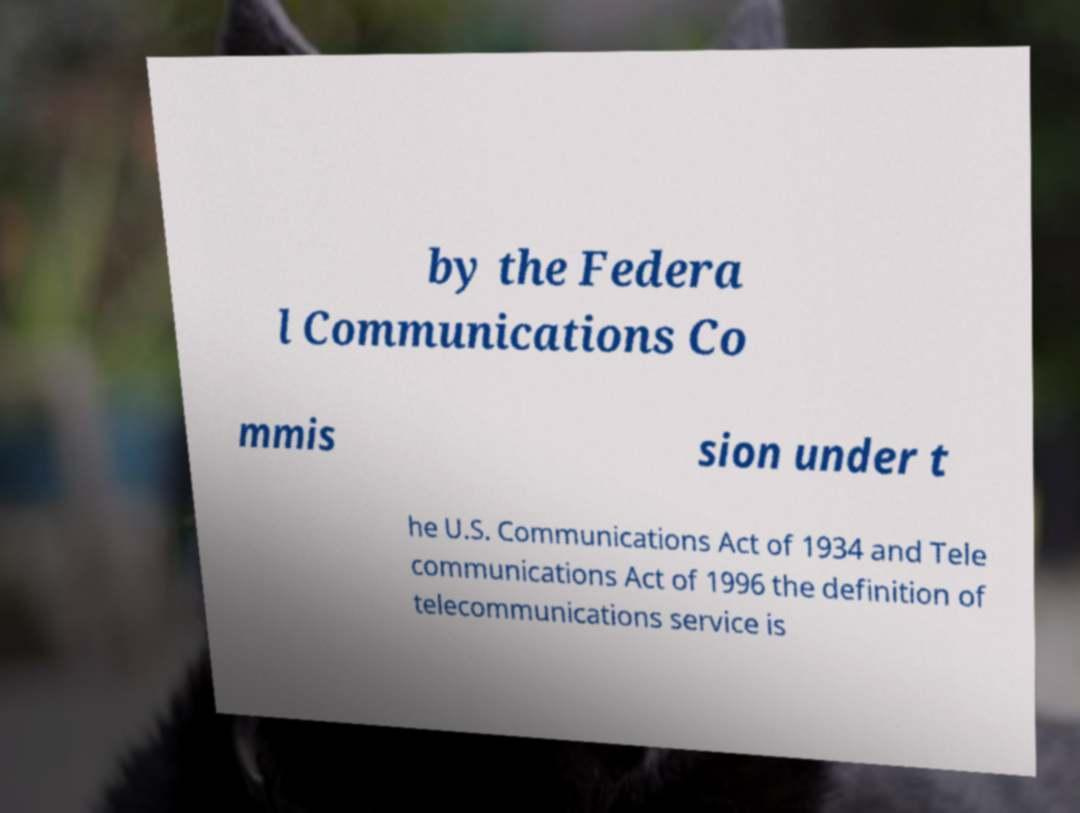Could you assist in decoding the text presented in this image and type it out clearly? by the Federa l Communications Co mmis sion under t he U.S. Communications Act of 1934 and Tele communications Act of 1996 the definition of telecommunications service is 